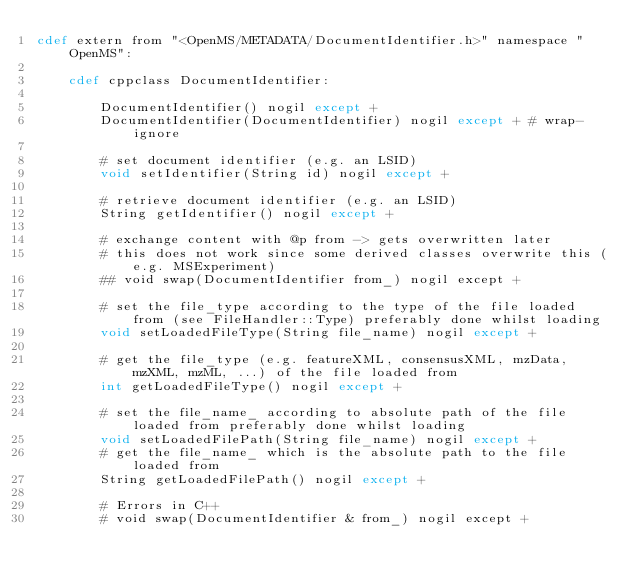<code> <loc_0><loc_0><loc_500><loc_500><_Cython_>cdef extern from "<OpenMS/METADATA/DocumentIdentifier.h>" namespace "OpenMS":

    cdef cppclass DocumentIdentifier:

        DocumentIdentifier() nogil except +
        DocumentIdentifier(DocumentIdentifier) nogil except + # wrap-ignore

        # set document identifier (e.g. an LSID)
        void setIdentifier(String id) nogil except +

        # retrieve document identifier (e.g. an LSID)
        String getIdentifier() nogil except +

        # exchange content with @p from -> gets overwritten later
        # this does not work since some derived classes overwrite this (e.g. MSExperiment)
        ## void swap(DocumentIdentifier from_) nogil except + 

        # set the file_type according to the type of the file loaded from (see FileHandler::Type) preferably done whilst loading
        void setLoadedFileType(String file_name) nogil except +

        # get the file_type (e.g. featureXML, consensusXML, mzData, mzXML, mzML, ...) of the file loaded from
        int getLoadedFileType() nogil except +

        # set the file_name_ according to absolute path of the file loaded from preferably done whilst loading
        void setLoadedFilePath(String file_name) nogil except +
        # get the file_name_ which is the absolute path to the file loaded from
        String getLoadedFilePath() nogil except +

        # Errors in C++
        # void swap(DocumentIdentifier & from_) nogil except +

</code> 